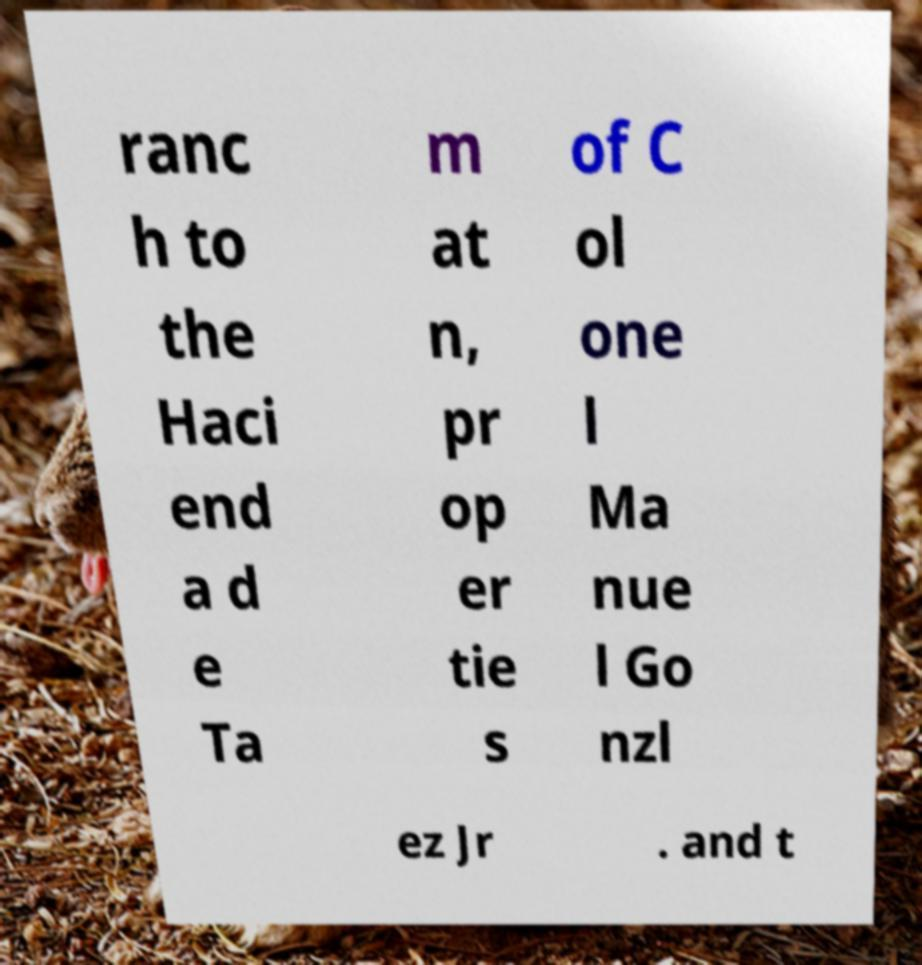What messages or text are displayed in this image? I need them in a readable, typed format. ranc h to the Haci end a d e Ta m at n, pr op er tie s of C ol one l Ma nue l Go nzl ez Jr . and t 